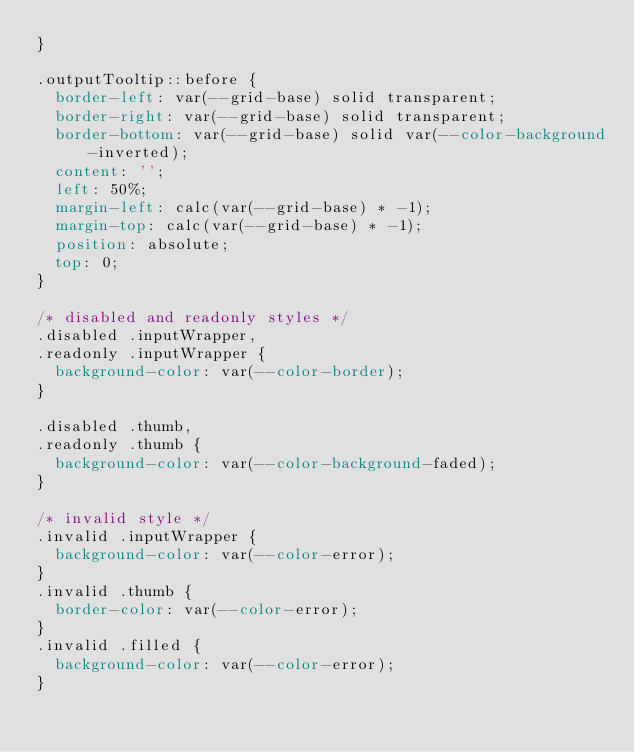Convert code to text. <code><loc_0><loc_0><loc_500><loc_500><_CSS_>}

.outputTooltip::before {
	border-left: var(--grid-base) solid transparent;
	border-right: var(--grid-base) solid transparent;
	border-bottom: var(--grid-base) solid var(--color-background-inverted);
	content: '';
	left: 50%;
	margin-left: calc(var(--grid-base) * -1);
	margin-top: calc(var(--grid-base) * -1);
	position: absolute;
	top: 0;
}

/* disabled and readonly styles */
.disabled .inputWrapper,
.readonly .inputWrapper {
	background-color: var(--color-border);
}

.disabled .thumb,
.readonly .thumb {
	background-color: var(--color-background-faded);
}

/* invalid style */
.invalid .inputWrapper {
	background-color: var(--color-error);
}
.invalid .thumb {
	border-color: var(--color-error);
}
.invalid .filled {
	background-color: var(--color-error);
}
</code> 